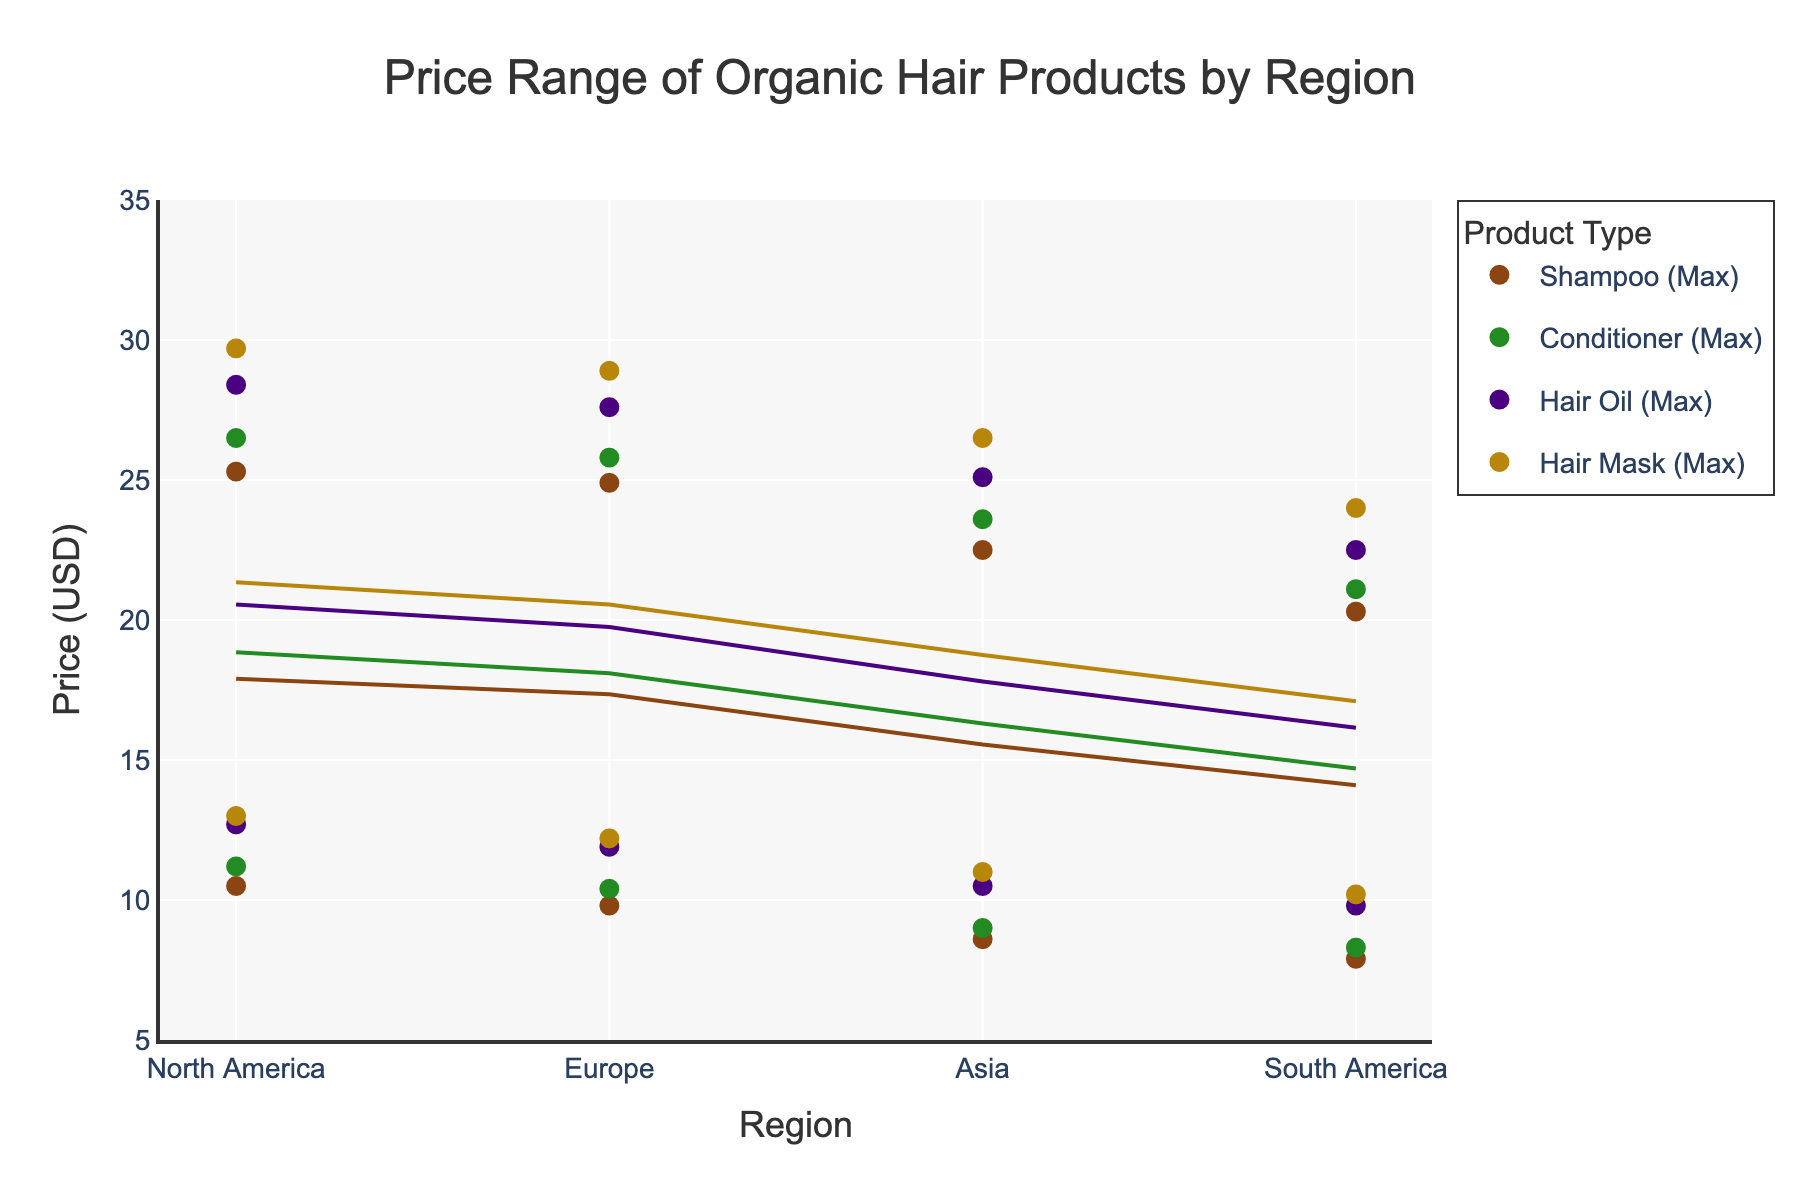what's the title of the figure? The title is typically positioned at the top of the figure. In this case, it says "Price Range of Organic Hair Products by Region".
Answer: Price Range of Organic Hair Products by Region how many regions are presented in the figure? The regions can be identified as distinct labels along the x-axis. By counting the labels, we find North America, Europe, Asia, and South America.
Answer: 4 which product type has the highest maximum average price in North America? Look at the maximum average prices of all product types in North America on the y-axis. The highest maximum price in North America is for Hair Mask.
Answer: Hair Mask what is the minimum average price of Shampoo in Europe? Locate the data points representing Shampoo in Europe. According to the y-axis, the minimum average price for Shampoo in Europe is 9.80.
Answer: 9.80 how does the price range of Conditioner in South America compare to that in Asia? The price range can be seen by examining the spread between the minimum and maximum average prices. In South America, the range for Conditioner is 8.30 to 21.10, while in Asia, it is 9.00 to 23.60. Therefore, Conditioner in South America has a smaller price range compared to Asia.
Answer: Smaller what's the average of the maximum average prices for Shampoos across all regions? Add up the maximum average prices for Shampoos in North America (25.30), Europe (24.90), Asia (22.50), and South America (20.30). The total is 93.00. Divide this by the 4 regions to get 93.00/4 = 23.25.
Answer: 23.25 which region has the lowest minimum average price for Hair Oil? Check the minimum average prices for Hair Oil in all regions. The lowest minimum price is in South America at 9.80.
Answer: South America among the products listed, which has the narrowest and widest price range in Asia? The price range is the difference between the maximum and minimum prices for each product in Asia. Calculate these:
  - Shampoo: 22.50 - 8.60 = 13.90
  - Conditioner: 23.60 - 9.00 = 14.60
  - Hair Oil: 25.10 - 10.50 = 14.60
  - Hair Mask: 26.50 - 11.00 = 15.50 The narrowest price range is for Shampoo (13.90) and the widest is for Hair Mask (15.50).
Answer: Shampoo, Hair Mask what can be inferred about the pricing consistency of Hair Masks across different regions? Evaluate the minimum and maximum prices for Hair Masks across all regions. If they don't vary too much, we can infer consistency. The ranges are fairly close: North America (13.00, 29.70), Europe (12.20, 28.90), Asia (11.00, 26.50), South America (10.20, 24.00). The prices are relatively consistent but slightly lower in South America.
Answer: Relatively consistent 